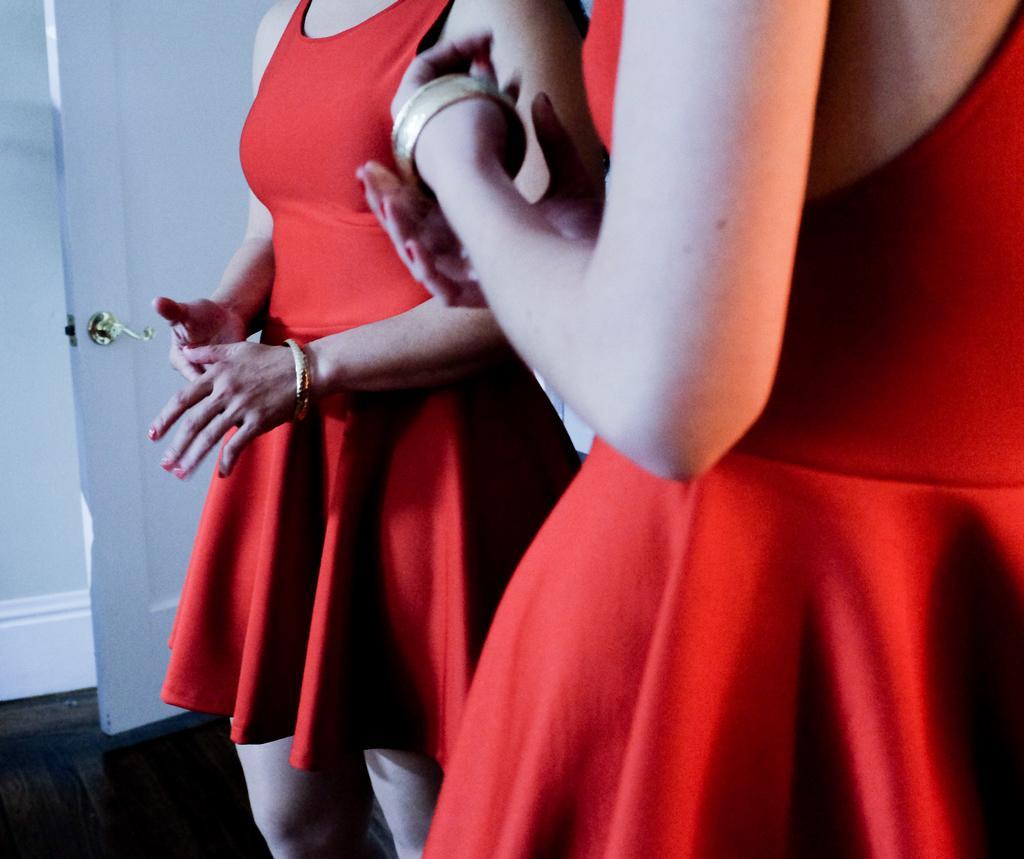In one or two sentences, can you explain what this image depicts? In this image we can see persons standing on the floor. 